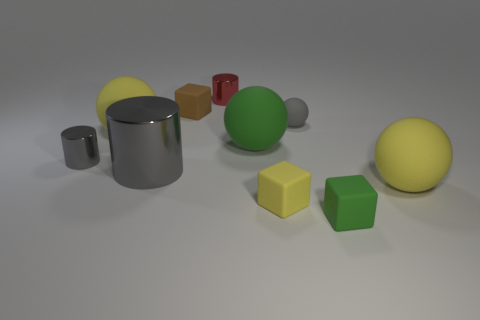Subtract all big spheres. How many spheres are left? 1 Subtract all gray balls. How many balls are left? 3 Subtract all balls. How many objects are left? 6 Subtract 2 blocks. How many blocks are left? 1 Subtract all big yellow things. Subtract all small yellow rubber cubes. How many objects are left? 7 Add 7 tiny yellow objects. How many tiny yellow objects are left? 8 Add 7 cyan matte spheres. How many cyan matte spheres exist? 7 Subtract 1 brown blocks. How many objects are left? 9 Subtract all yellow cylinders. Subtract all green spheres. How many cylinders are left? 3 Subtract all yellow cylinders. How many gray spheres are left? 1 